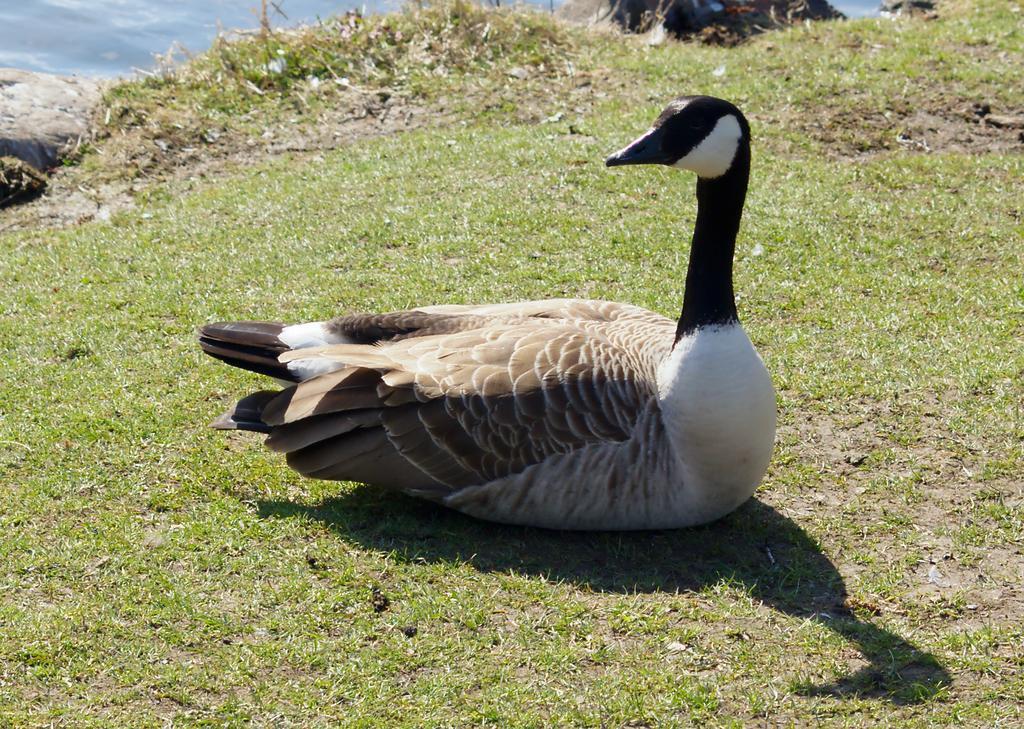Could you give a brief overview of what you see in this image? In the center of the image there is a duck on the grass. In the background we can see water and grass. 